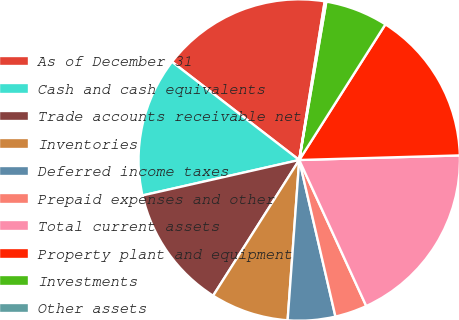Convert chart. <chart><loc_0><loc_0><loc_500><loc_500><pie_chart><fcel>As of December 31<fcel>Cash and cash equivalents<fcel>Trade accounts receivable net<fcel>Inventories<fcel>Deferred income taxes<fcel>Prepaid expenses and other<fcel>Total current assets<fcel>Property plant and equipment<fcel>Investments<fcel>Other assets<nl><fcel>17.08%<fcel>14.0%<fcel>12.46%<fcel>7.85%<fcel>4.77%<fcel>3.23%<fcel>18.61%<fcel>15.54%<fcel>6.31%<fcel>0.16%<nl></chart> 